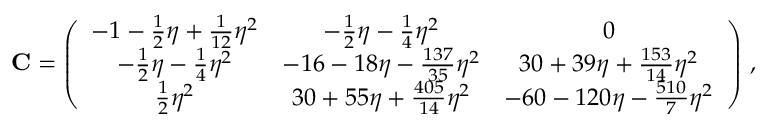Convert formula to latex. <formula><loc_0><loc_0><loc_500><loc_500>{ C } = \left ( \begin{array} { c c c } { - 1 - \frac { 1 } { 2 } \eta + \frac { 1 } { 1 2 } \eta ^ { 2 } } & { - \frac { 1 } { 2 } \eta - \frac { 1 } { 4 } \eta ^ { 2 } } & { 0 } \\ { - \frac { 1 } { 2 } \eta - \frac { 1 } { 4 } \eta ^ { 2 } } & { - 1 6 - 1 8 \eta - \frac { 1 3 7 } { 3 5 } \eta ^ { 2 } } & { 3 0 + 3 9 \eta + \frac { 1 5 3 } { 1 4 } \eta ^ { 2 } } \\ { \frac { 1 } { 2 } \eta ^ { 2 } } & { 3 0 + 5 5 \eta + \frac { 4 0 5 } { 1 4 } \eta ^ { 2 } } & { - 6 0 - 1 2 0 \eta - \frac { 5 1 0 } { 7 } \eta ^ { 2 } } \end{array} \right ) \, ,</formula> 